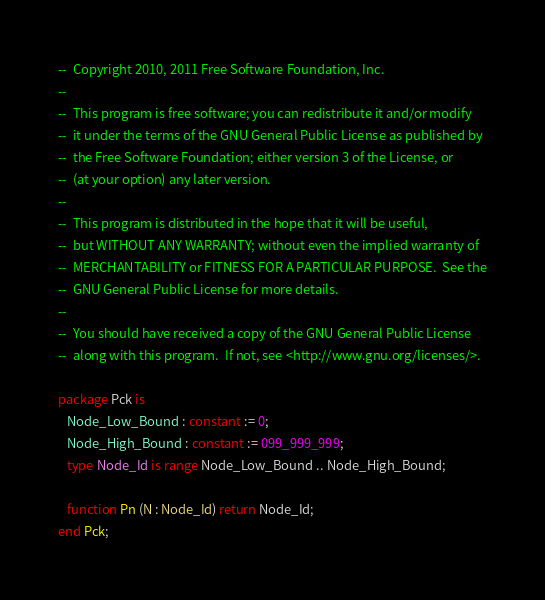<code> <loc_0><loc_0><loc_500><loc_500><_Ada_>--  Copyright 2010, 2011 Free Software Foundation, Inc.
--
--  This program is free software; you can redistribute it and/or modify
--  it under the terms of the GNU General Public License as published by
--  the Free Software Foundation; either version 3 of the License, or
--  (at your option) any later version.
--
--  This program is distributed in the hope that it will be useful,
--  but WITHOUT ANY WARRANTY; without even the implied warranty of
--  MERCHANTABILITY or FITNESS FOR A PARTICULAR PURPOSE.  See the
--  GNU General Public License for more details.
--
--  You should have received a copy of the GNU General Public License
--  along with this program.  If not, see <http://www.gnu.org/licenses/>.

package Pck is
   Node_Low_Bound : constant := 0;
   Node_High_Bound : constant := 099_999_999;
   type Node_Id is range Node_Low_Bound .. Node_High_Bound;

   function Pn (N : Node_Id) return Node_Id;
end Pck;

</code> 